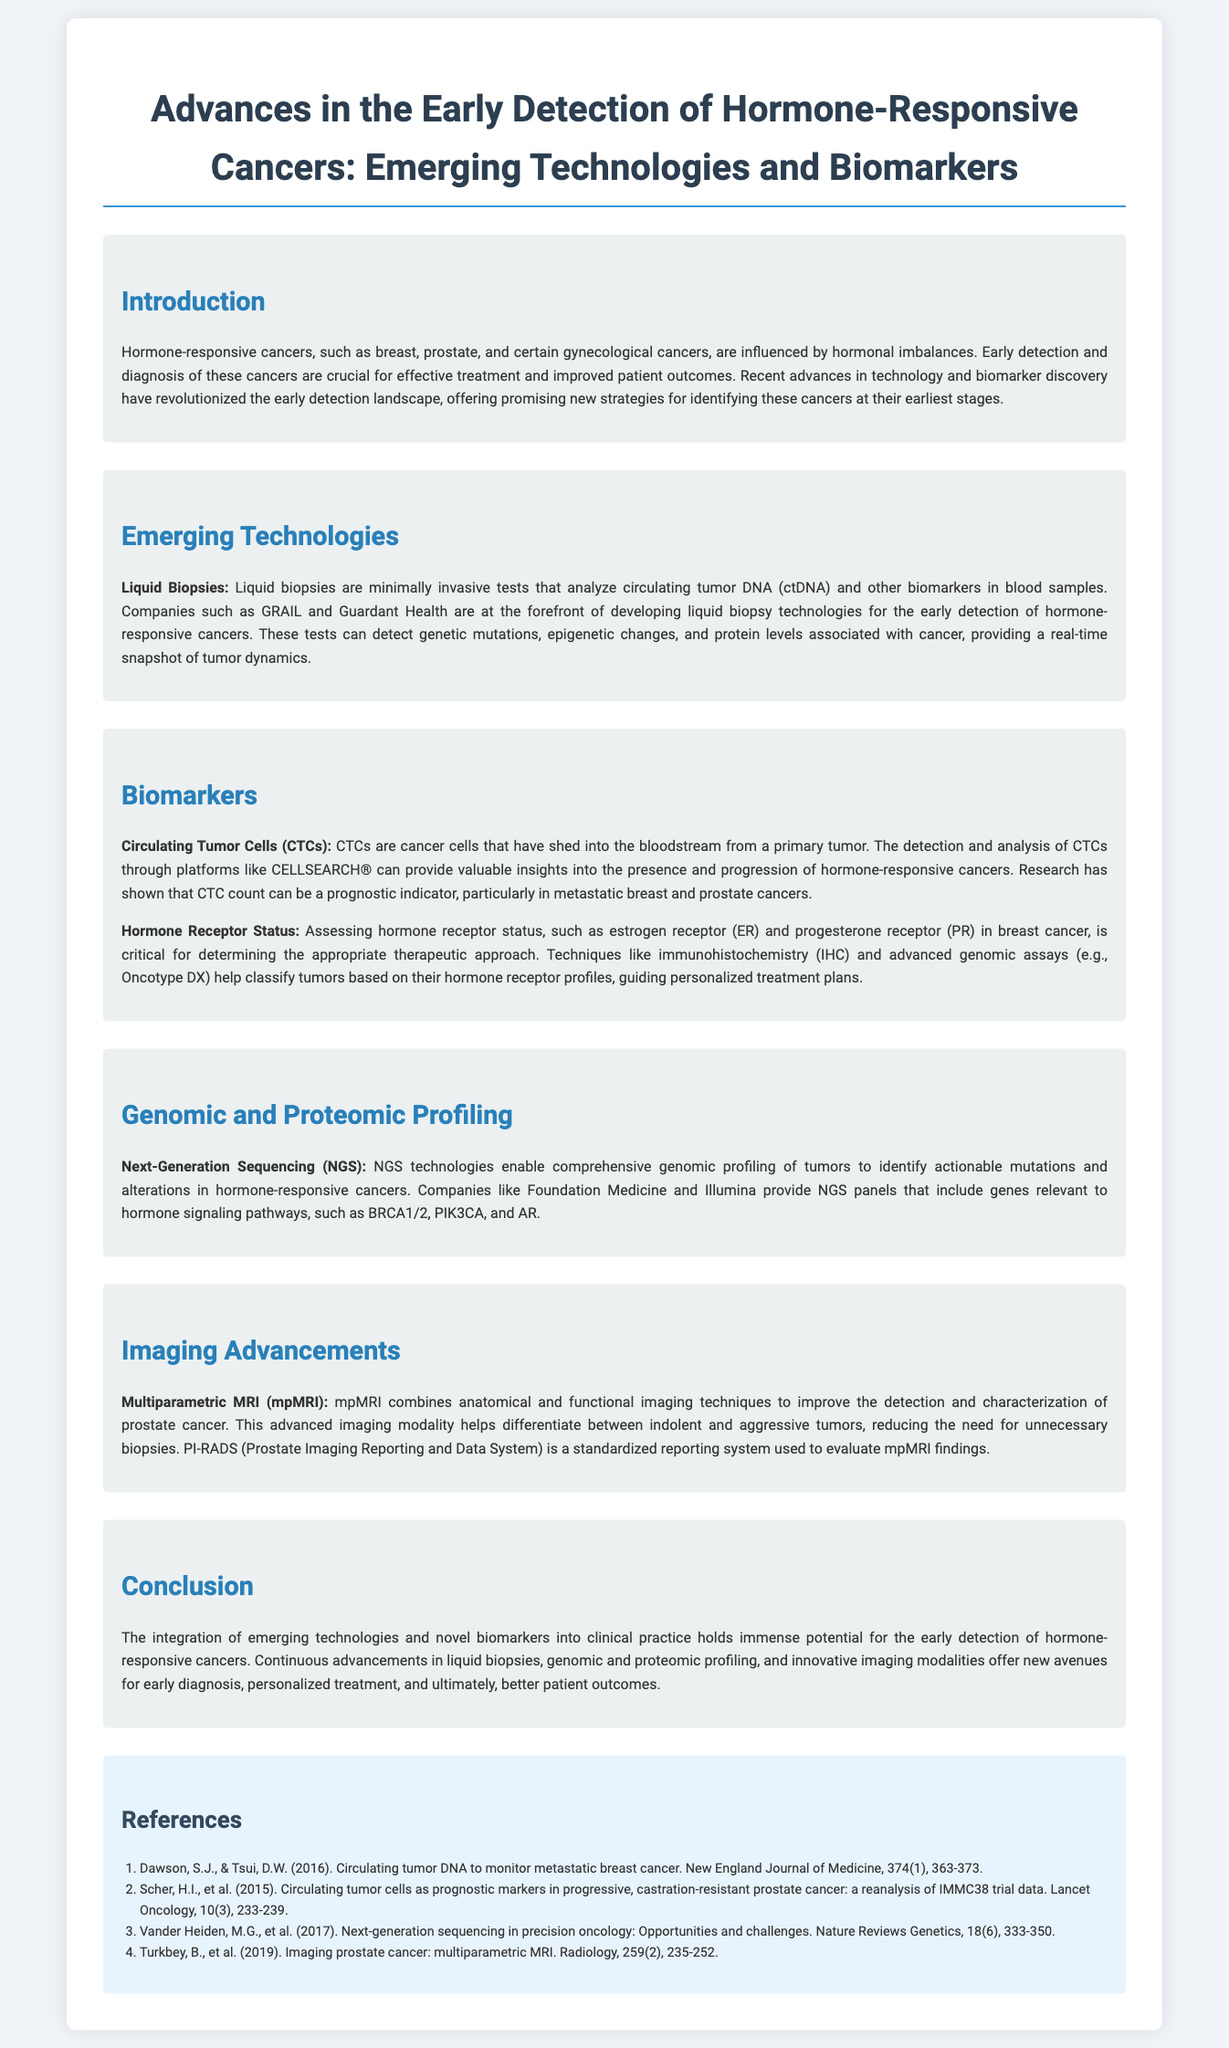What are examples of hormone-responsive cancers mentioned? The document lists breast, prostate, and certain gynecological cancers as examples of hormone-responsive cancers.
Answer: breast, prostate, gynecological cancers What is a key benefit of liquid biopsies? The document states that liquid biopsies provide a real-time snapshot of tumor dynamics by analyzing circulating tumor DNA and other biomarkers.
Answer: real-time snapshot of tumor dynamics Which platform is used for detecting circulating tumor cells? The platform mentioned for detecting circulating tumor cells is CELLSEARCH®.
Answer: CELLSEARCH® What genomic profiling technology is highlighted in the document? Next-Generation Sequencing (NGS) is highlighted as a genomic profiling technology in the document.
Answer: Next-Generation Sequencing (NGS) What imaging technique is discussed for prostate cancer detection? The document discusses multiparametric MRI (mpMRI) as an imaging technique for prostate cancer detection.
Answer: multiparametric MRI (mpMRI) What does CTC stand for? CTC stands for circulating tumor cells, as described in the document.
Answer: circulating tumor cells What is PI-RADS used for? PI-RADS is used to evaluate mpMRI findings in the context of prostate cancer.
Answer: evaluate mpMRI findings How do hormone receptor status assessments influence treatment? The assessments help determine the appropriate therapeutic approach for hormone-responsive cancers.
Answer: determine the appropriate therapeutic approach 